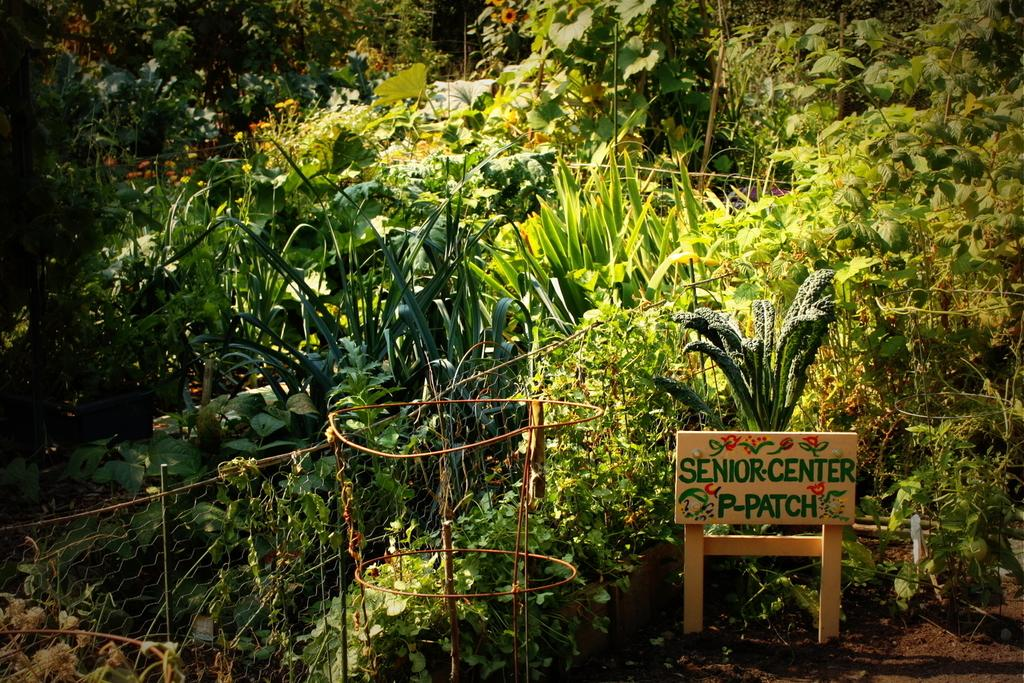What type of living organisms can be seen in the image? There is a group of plants in the image. What material is the fence in the image made of? The fence in the image is made of metal. What is located on the right side of the image? There is a board with text on the right side of the image. What type of mask is being worn by the moon in the image? There is no moon or mask present in the image. How does the spark interact with the plants in the image? There is no spark present in the image. 